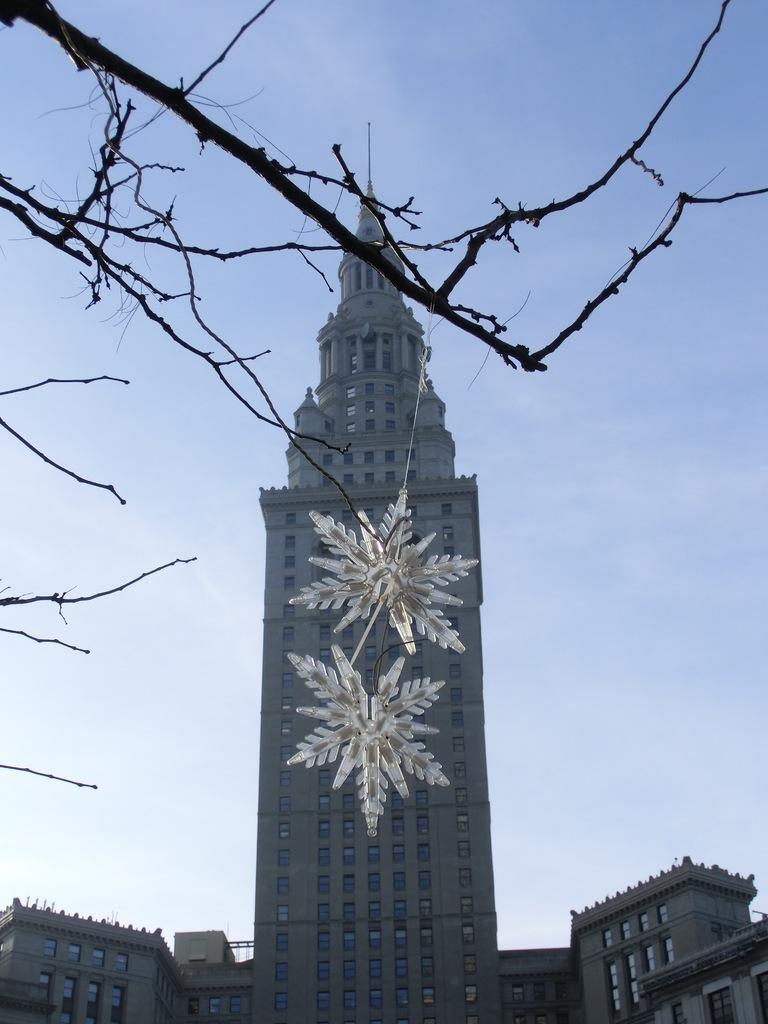What type of structure is present in the image? There is a building in the image. Can you describe any additional details about the building? Unfortunately, the provided facts do not offer any additional details about the building. What is hanging from a tree branch in the image? There is a decorative item hanging from a tree branch in the image. What can be seen in the background of the image? The sky is visible in the background of the image. What type of match is being played in the image? There is no match or game being played in the image; it features a building and a decorative item hanging from a tree branch. 